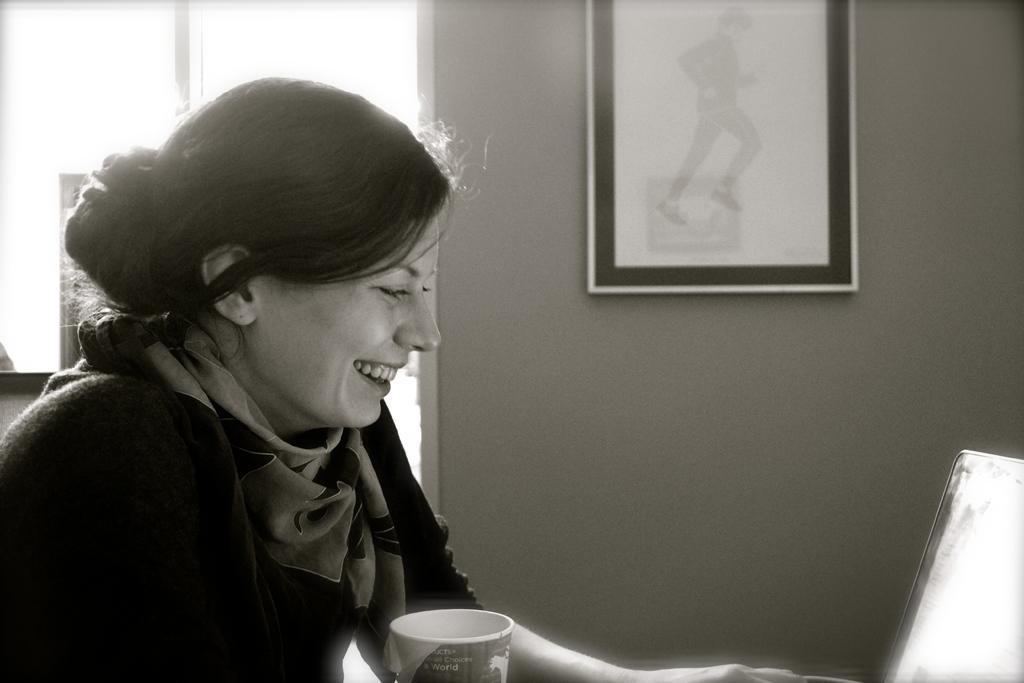Can you describe this image briefly? In this picture I can see a woman smiling, there is a cup, laptop, there are some other items, and in the background there is a window and a frame attached to the wall. 